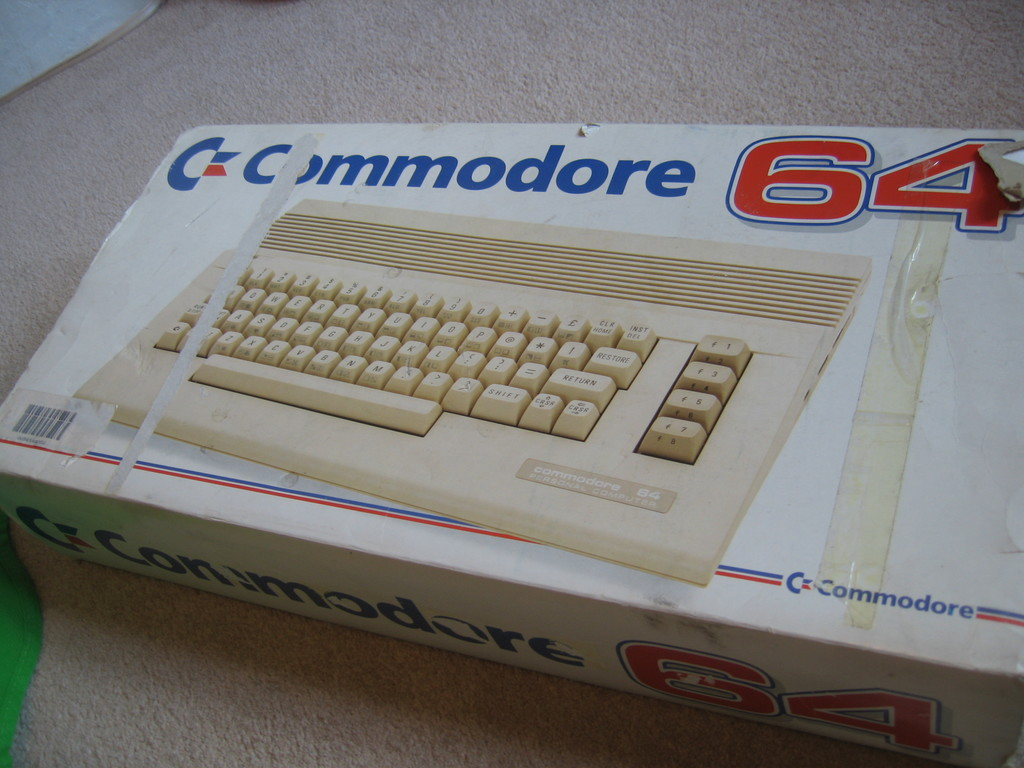Can you explain the historical significance of the Commodore 64? Certainly! The Commodore 64, introduced in 1982, was a groundbreaking home computer renowned for its affordability and versatility. It offered color graphics and sound capabilities that were superior at the time, making it popular for gaming, educational software, and home office use. Its influence stretched well into the 1990s, making it a pivotal piece in personal computing history. 